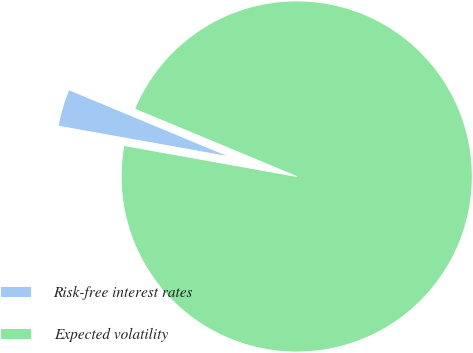<chart> <loc_0><loc_0><loc_500><loc_500><pie_chart><fcel>Risk-free interest rates<fcel>Expected volatility<nl><fcel>3.45%<fcel>96.55%<nl></chart> 